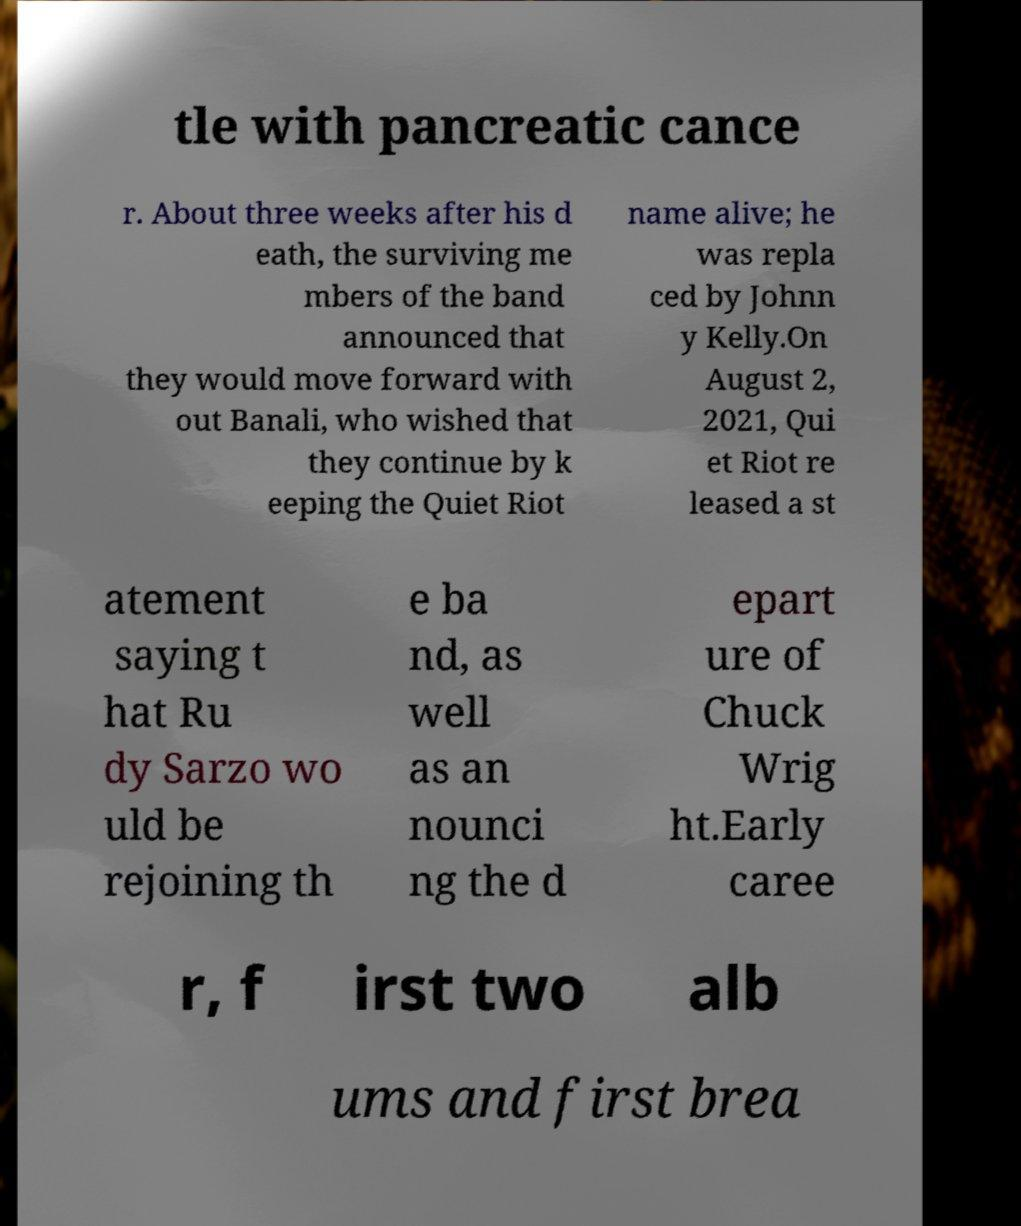I need the written content from this picture converted into text. Can you do that? tle with pancreatic cance r. About three weeks after his d eath, the surviving me mbers of the band announced that they would move forward with out Banali, who wished that they continue by k eeping the Quiet Riot name alive; he was repla ced by Johnn y Kelly.On August 2, 2021, Qui et Riot re leased a st atement saying t hat Ru dy Sarzo wo uld be rejoining th e ba nd, as well as an nounci ng the d epart ure of Chuck Wrig ht.Early caree r, f irst two alb ums and first brea 